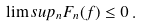Convert formula to latex. <formula><loc_0><loc_0><loc_500><loc_500>\lim s u p _ { n } F _ { n } ( f ) \leq 0 \, .</formula> 